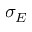Convert formula to latex. <formula><loc_0><loc_0><loc_500><loc_500>\sigma _ { E }</formula> 